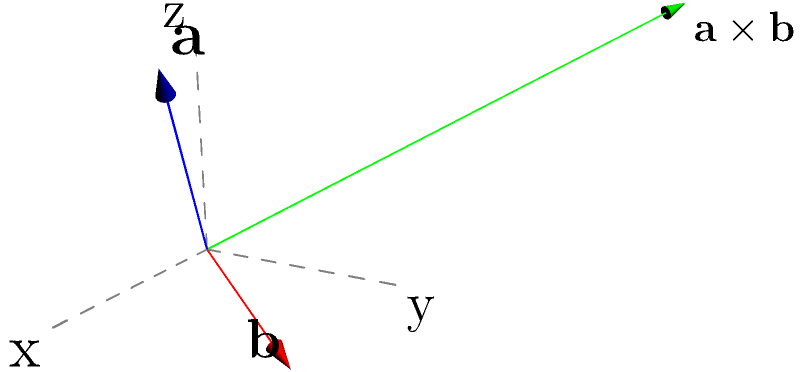Given two vectors $\mathbf{a} = (2,1,3)$ and $\mathbf{b} = (1,2,-1)$, calculate their cross product $\mathbf{a} \times \mathbf{b}$ and describe its geometric significance. How does the resulting vector relate to the original vectors in terms of direction and magnitude? To solve this problem, let's follow these steps:

1) The cross product of two vectors $\mathbf{a} = (a_1, a_2, a_3)$ and $\mathbf{b} = (b_1, b_2, b_3)$ is given by:

   $\mathbf{a} \times \mathbf{b} = (a_2b_3 - a_3b_2, a_3b_1 - a_1b_3, a_1b_2 - a_2b_1)$

2) Substituting the values:
   $\mathbf{a} = (2,1,3)$ and $\mathbf{b} = (1,2,-1)$

3) Calculate each component:
   - $a_2b_3 - a_3b_2 = 1(-1) - 3(2) = -1 - 6 = -7$
   - $a_3b_1 - a_1b_3 = 3(1) - 2(-1) = 3 + 2 = 5$
   - $a_1b_2 - a_2b_1 = 2(2) - 1(1) = 4 - 1 = 3$

4) Therefore, $\mathbf{a} \times \mathbf{b} = (-7, 5, 3)$

Geometric significance:
- The cross product vector is perpendicular to both $\mathbf{a}$ and $\mathbf{b}$.
- Its magnitude is equal to the area of the parallelogram formed by $\mathbf{a}$ and $\mathbf{b}$.
- The direction follows the right-hand rule: if you curl the fingers of your right hand from $\mathbf{a}$ to $\mathbf{b}$, your thumb points in the direction of $\mathbf{a} \times \mathbf{b}$.

Relation to original vectors:
- Direction: Perpendicular to both $\mathbf{a}$ and $\mathbf{b}$.
- Magnitude: $|\mathbf{a} \times \mathbf{b}| = |\mathbf{a}||\mathbf{b}|\sin\theta$, where $\theta$ is the angle between $\mathbf{a}$ and $\mathbf{b}$.
Answer: $\mathbf{a} \times \mathbf{b} = (-7, 5, 3)$; perpendicular to both $\mathbf{a}$ and $\mathbf{b}$ 